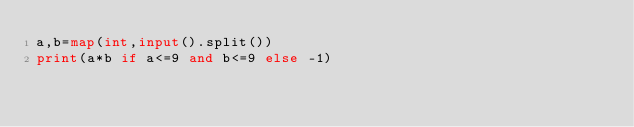<code> <loc_0><loc_0><loc_500><loc_500><_Python_>a,b=map(int,input().split())
print(a*b if a<=9 and b<=9 else -1)</code> 